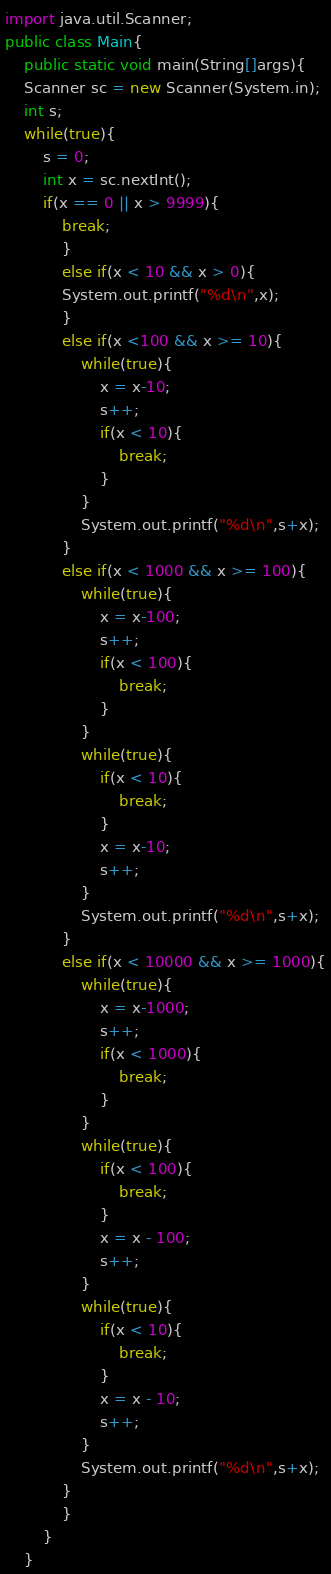<code> <loc_0><loc_0><loc_500><loc_500><_Java_>import java.util.Scanner;
public class Main{
	public static void main(String[]args){
	Scanner sc = new Scanner(System.in);
	int s;
	while(true){
		s = 0;
		int x = sc.nextInt();
		if(x == 0 || x > 9999){
			break;
			}
			else if(x < 10 && x > 0){
			System.out.printf("%d\n",x);
			}
			else if(x <100 && x >= 10){
				while(true){
					x = x-10;
					s++;
					if(x < 10){
						break;
					}
				}
				System.out.printf("%d\n",s+x);
			}
			else if(x < 1000 && x >= 100){
				while(true){
					x = x-100;
					s++;
					if(x < 100){
						break;
					}
				}
				while(true){
					if(x < 10){
						break;
					}
					x = x-10;
					s++;
				}
				System.out.printf("%d\n",s+x);
			}
			else if(x < 10000 && x >= 1000){
				while(true){
					x = x-1000;
					s++;
					if(x < 1000){
						break;
					}
				}
				while(true){
					if(x < 100){
						break;
					}
					x = x - 100;
					s++;
				}
				while(true){
					if(x < 10){
						break;
					}
					x = x - 10;
					s++;
				}
				System.out.printf("%d\n",s+x);
			}
			}
		}
	}</code> 